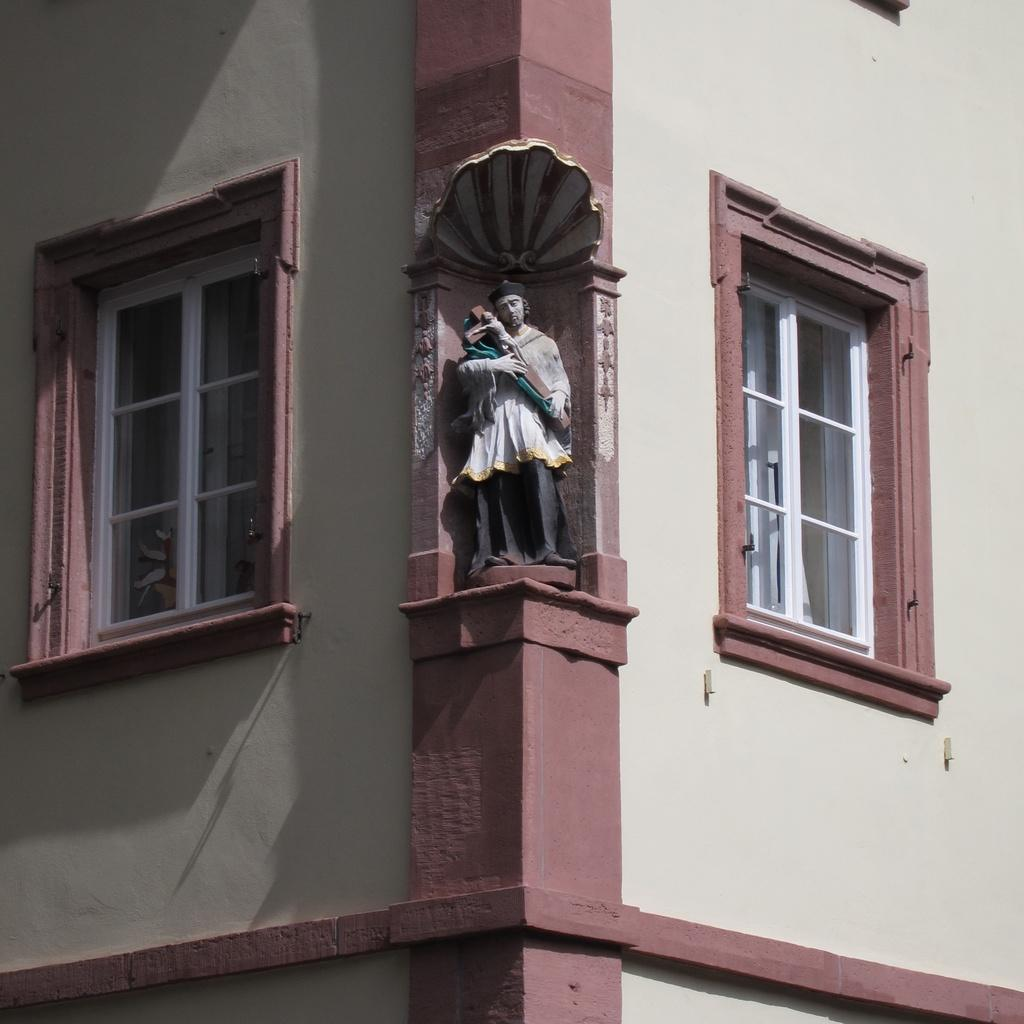What type of structure is visible in the image? There is a building in the image. What feature can be seen on the building? The building has windows. What additional object is present in the image? There is a sculpture in the image. What type of bait is being used to catch fish in the image? There is no fishing or bait present in the image; it features a building with windows and a sculpture. 